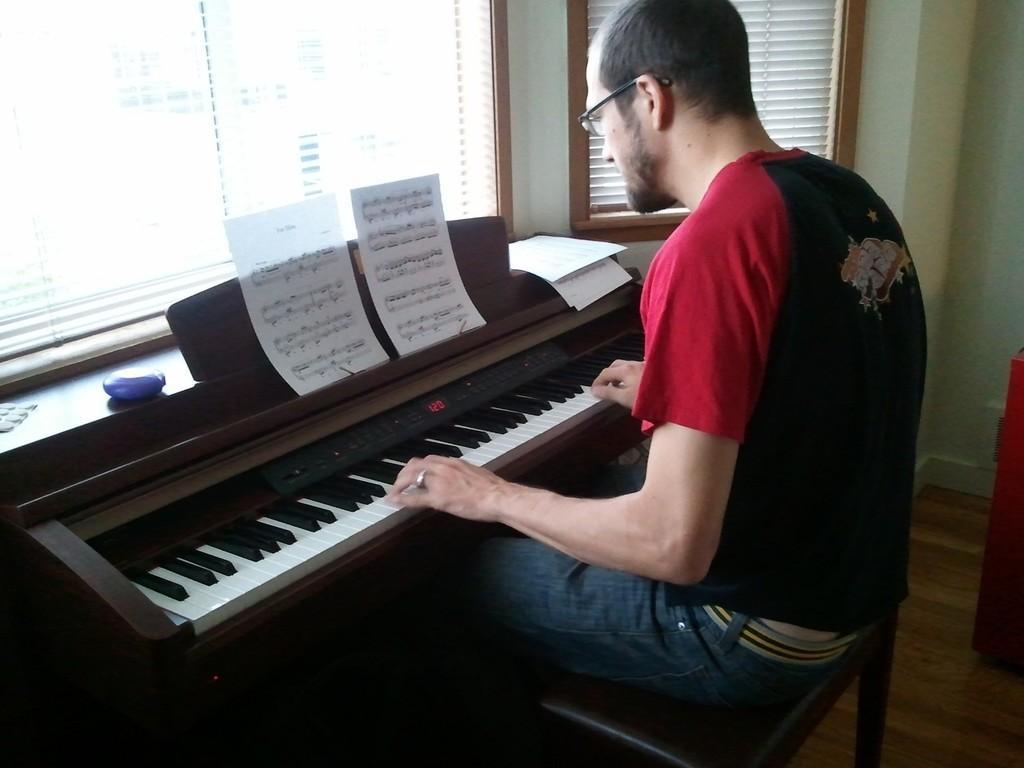In one or two sentences, can you explain what this image depicts? In the image there is man sat on chair playing piano,it's inside a room. 